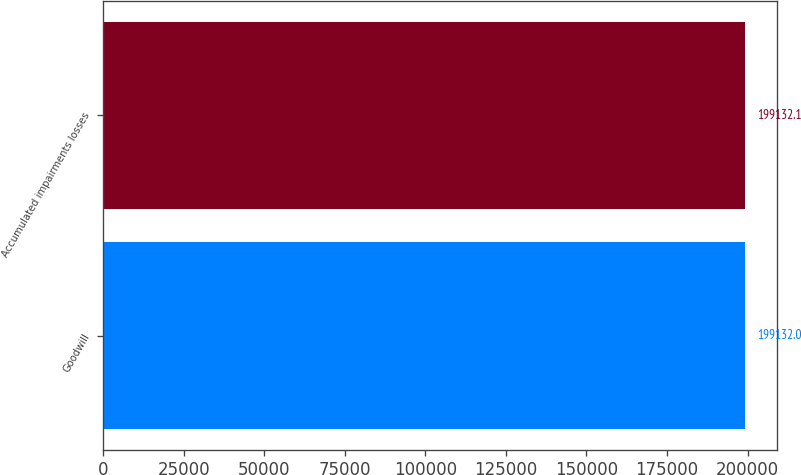Convert chart. <chart><loc_0><loc_0><loc_500><loc_500><bar_chart><fcel>Goodwill<fcel>Accumulated impairments losses<nl><fcel>199132<fcel>199132<nl></chart> 